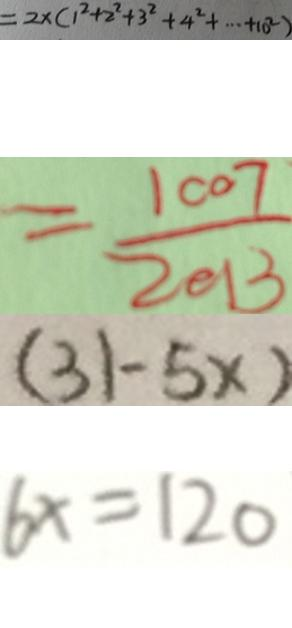<formula> <loc_0><loc_0><loc_500><loc_500>= 2 \times ( 1 ^ { 2 } + 2 ^ { 2 } + 3 ^ { 2 } + 4 ^ { 2 } + \cdots 1 0 ^ { 2 } ) 
 = \frac { 1 0 0 7 } { 2 0 1 3 } 
 ( 3 1 - 5 x ) 
 6 x = 1 2 0</formula> 